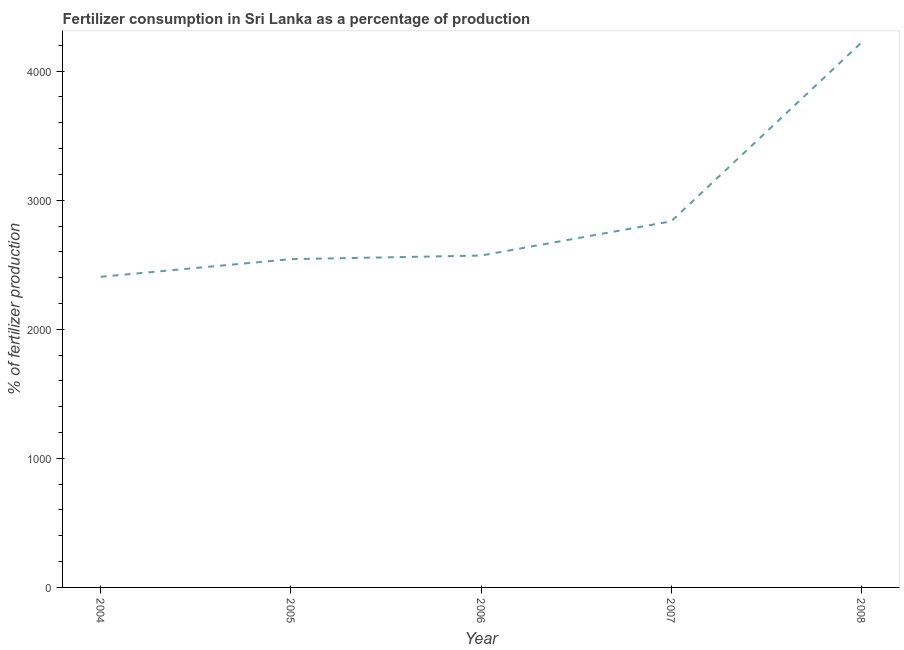What is the amount of fertilizer consumption in 2004?
Your response must be concise. 2406.46. Across all years, what is the maximum amount of fertilizer consumption?
Your response must be concise. 4221.35. Across all years, what is the minimum amount of fertilizer consumption?
Provide a short and direct response. 2406.46. In which year was the amount of fertilizer consumption maximum?
Ensure brevity in your answer.  2008. In which year was the amount of fertilizer consumption minimum?
Your answer should be compact. 2004. What is the sum of the amount of fertilizer consumption?
Provide a succinct answer. 1.46e+04. What is the difference between the amount of fertilizer consumption in 2004 and 2007?
Offer a terse response. -430.01. What is the average amount of fertilizer consumption per year?
Your response must be concise. 2915.71. What is the median amount of fertilizer consumption?
Give a very brief answer. 2571.08. In how many years, is the amount of fertilizer consumption greater than 2400 %?
Your response must be concise. 5. Do a majority of the years between 2006 and 2004 (inclusive) have amount of fertilizer consumption greater than 1600 %?
Your response must be concise. No. What is the ratio of the amount of fertilizer consumption in 2007 to that in 2008?
Give a very brief answer. 0.67. Is the amount of fertilizer consumption in 2004 less than that in 2008?
Provide a succinct answer. Yes. What is the difference between the highest and the second highest amount of fertilizer consumption?
Offer a terse response. 1384.89. What is the difference between the highest and the lowest amount of fertilizer consumption?
Your response must be concise. 1814.9. Does the amount of fertilizer consumption monotonically increase over the years?
Your answer should be compact. Yes. How many years are there in the graph?
Offer a very short reply. 5. Are the values on the major ticks of Y-axis written in scientific E-notation?
Make the answer very short. No. Does the graph contain any zero values?
Keep it short and to the point. No. What is the title of the graph?
Keep it short and to the point. Fertilizer consumption in Sri Lanka as a percentage of production. What is the label or title of the X-axis?
Provide a short and direct response. Year. What is the label or title of the Y-axis?
Provide a short and direct response. % of fertilizer production. What is the % of fertilizer production in 2004?
Keep it short and to the point. 2406.46. What is the % of fertilizer production of 2005?
Make the answer very short. 2543.21. What is the % of fertilizer production of 2006?
Make the answer very short. 2571.08. What is the % of fertilizer production in 2007?
Give a very brief answer. 2836.46. What is the % of fertilizer production in 2008?
Ensure brevity in your answer.  4221.35. What is the difference between the % of fertilizer production in 2004 and 2005?
Your answer should be very brief. -136.75. What is the difference between the % of fertilizer production in 2004 and 2006?
Provide a short and direct response. -164.62. What is the difference between the % of fertilizer production in 2004 and 2007?
Give a very brief answer. -430.01. What is the difference between the % of fertilizer production in 2004 and 2008?
Give a very brief answer. -1814.9. What is the difference between the % of fertilizer production in 2005 and 2006?
Your answer should be compact. -27.87. What is the difference between the % of fertilizer production in 2005 and 2007?
Give a very brief answer. -293.26. What is the difference between the % of fertilizer production in 2005 and 2008?
Your answer should be very brief. -1678.14. What is the difference between the % of fertilizer production in 2006 and 2007?
Your answer should be compact. -265.39. What is the difference between the % of fertilizer production in 2006 and 2008?
Your answer should be very brief. -1650.28. What is the difference between the % of fertilizer production in 2007 and 2008?
Make the answer very short. -1384.89. What is the ratio of the % of fertilizer production in 2004 to that in 2005?
Make the answer very short. 0.95. What is the ratio of the % of fertilizer production in 2004 to that in 2006?
Keep it short and to the point. 0.94. What is the ratio of the % of fertilizer production in 2004 to that in 2007?
Provide a succinct answer. 0.85. What is the ratio of the % of fertilizer production in 2004 to that in 2008?
Make the answer very short. 0.57. What is the ratio of the % of fertilizer production in 2005 to that in 2006?
Give a very brief answer. 0.99. What is the ratio of the % of fertilizer production in 2005 to that in 2007?
Give a very brief answer. 0.9. What is the ratio of the % of fertilizer production in 2005 to that in 2008?
Provide a succinct answer. 0.6. What is the ratio of the % of fertilizer production in 2006 to that in 2007?
Provide a succinct answer. 0.91. What is the ratio of the % of fertilizer production in 2006 to that in 2008?
Offer a terse response. 0.61. What is the ratio of the % of fertilizer production in 2007 to that in 2008?
Make the answer very short. 0.67. 